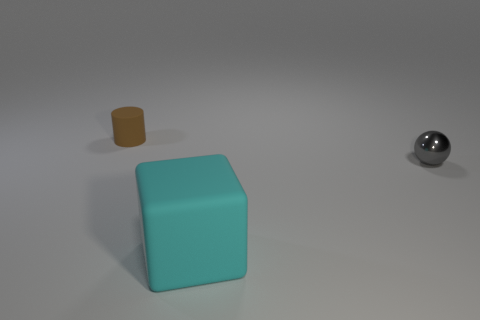Add 2 cylinders. How many objects exist? 5 Subtract all spheres. How many objects are left? 2 Subtract 0 purple blocks. How many objects are left? 3 Subtract all gray things. Subtract all brown matte things. How many objects are left? 1 Add 1 tiny gray shiny spheres. How many tiny gray shiny spheres are left? 2 Add 2 rubber cylinders. How many rubber cylinders exist? 3 